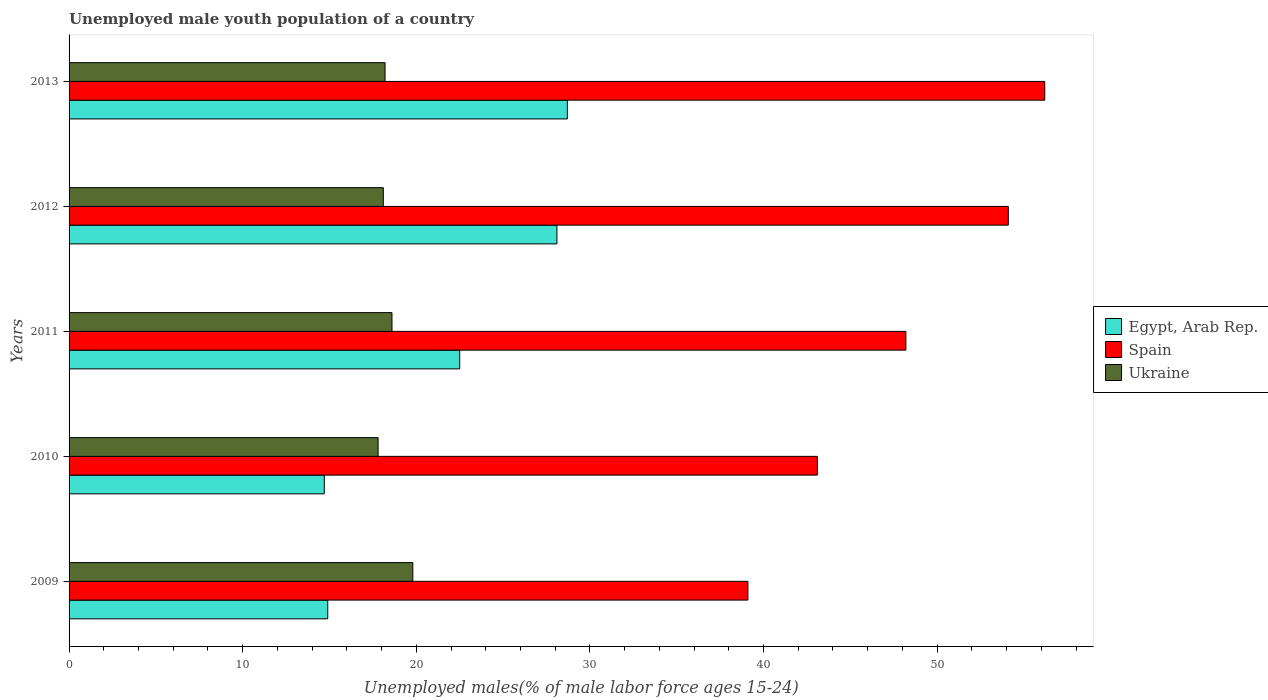How many different coloured bars are there?
Provide a short and direct response. 3. Are the number of bars on each tick of the Y-axis equal?
Your answer should be very brief. Yes. How many bars are there on the 1st tick from the bottom?
Give a very brief answer. 3. What is the label of the 1st group of bars from the top?
Provide a short and direct response. 2013. In how many cases, is the number of bars for a given year not equal to the number of legend labels?
Make the answer very short. 0. What is the percentage of unemployed male youth population in Ukraine in 2011?
Provide a short and direct response. 18.6. Across all years, what is the maximum percentage of unemployed male youth population in Spain?
Keep it short and to the point. 56.2. Across all years, what is the minimum percentage of unemployed male youth population in Spain?
Offer a very short reply. 39.1. What is the total percentage of unemployed male youth population in Ukraine in the graph?
Give a very brief answer. 92.5. What is the difference between the percentage of unemployed male youth population in Egypt, Arab Rep. in 2009 and that in 2010?
Your answer should be compact. 0.2. What is the difference between the percentage of unemployed male youth population in Egypt, Arab Rep. in 2009 and the percentage of unemployed male youth population in Spain in 2013?
Your answer should be compact. -41.3. What is the average percentage of unemployed male youth population in Ukraine per year?
Offer a terse response. 18.5. In the year 2009, what is the difference between the percentage of unemployed male youth population in Egypt, Arab Rep. and percentage of unemployed male youth population in Ukraine?
Offer a terse response. -4.9. In how many years, is the percentage of unemployed male youth population in Ukraine greater than 18 %?
Make the answer very short. 4. What is the ratio of the percentage of unemployed male youth population in Egypt, Arab Rep. in 2011 to that in 2012?
Your answer should be very brief. 0.8. Is the difference between the percentage of unemployed male youth population in Egypt, Arab Rep. in 2011 and 2013 greater than the difference between the percentage of unemployed male youth population in Ukraine in 2011 and 2013?
Provide a short and direct response. No. What is the difference between the highest and the second highest percentage of unemployed male youth population in Spain?
Provide a succinct answer. 2.1. What is the difference between the highest and the lowest percentage of unemployed male youth population in Spain?
Give a very brief answer. 17.1. What does the 3rd bar from the top in 2013 represents?
Give a very brief answer. Egypt, Arab Rep. What does the 1st bar from the bottom in 2010 represents?
Your answer should be very brief. Egypt, Arab Rep. Is it the case that in every year, the sum of the percentage of unemployed male youth population in Ukraine and percentage of unemployed male youth population in Spain is greater than the percentage of unemployed male youth population in Egypt, Arab Rep.?
Offer a very short reply. Yes. Are all the bars in the graph horizontal?
Provide a short and direct response. Yes. What is the difference between two consecutive major ticks on the X-axis?
Provide a succinct answer. 10. Are the values on the major ticks of X-axis written in scientific E-notation?
Offer a very short reply. No. Does the graph contain grids?
Keep it short and to the point. No. Where does the legend appear in the graph?
Provide a short and direct response. Center right. How many legend labels are there?
Give a very brief answer. 3. How are the legend labels stacked?
Provide a short and direct response. Vertical. What is the title of the graph?
Keep it short and to the point. Unemployed male youth population of a country. What is the label or title of the X-axis?
Keep it short and to the point. Unemployed males(% of male labor force ages 15-24). What is the label or title of the Y-axis?
Make the answer very short. Years. What is the Unemployed males(% of male labor force ages 15-24) of Egypt, Arab Rep. in 2009?
Give a very brief answer. 14.9. What is the Unemployed males(% of male labor force ages 15-24) in Spain in 2009?
Your answer should be very brief. 39.1. What is the Unemployed males(% of male labor force ages 15-24) in Ukraine in 2009?
Ensure brevity in your answer.  19.8. What is the Unemployed males(% of male labor force ages 15-24) in Egypt, Arab Rep. in 2010?
Your answer should be compact. 14.7. What is the Unemployed males(% of male labor force ages 15-24) in Spain in 2010?
Provide a succinct answer. 43.1. What is the Unemployed males(% of male labor force ages 15-24) of Ukraine in 2010?
Give a very brief answer. 17.8. What is the Unemployed males(% of male labor force ages 15-24) in Spain in 2011?
Make the answer very short. 48.2. What is the Unemployed males(% of male labor force ages 15-24) in Ukraine in 2011?
Provide a short and direct response. 18.6. What is the Unemployed males(% of male labor force ages 15-24) of Egypt, Arab Rep. in 2012?
Keep it short and to the point. 28.1. What is the Unemployed males(% of male labor force ages 15-24) of Spain in 2012?
Ensure brevity in your answer.  54.1. What is the Unemployed males(% of male labor force ages 15-24) of Ukraine in 2012?
Give a very brief answer. 18.1. What is the Unemployed males(% of male labor force ages 15-24) in Egypt, Arab Rep. in 2013?
Make the answer very short. 28.7. What is the Unemployed males(% of male labor force ages 15-24) of Spain in 2013?
Keep it short and to the point. 56.2. What is the Unemployed males(% of male labor force ages 15-24) of Ukraine in 2013?
Your answer should be very brief. 18.2. Across all years, what is the maximum Unemployed males(% of male labor force ages 15-24) in Egypt, Arab Rep.?
Your answer should be compact. 28.7. Across all years, what is the maximum Unemployed males(% of male labor force ages 15-24) in Spain?
Make the answer very short. 56.2. Across all years, what is the maximum Unemployed males(% of male labor force ages 15-24) in Ukraine?
Provide a short and direct response. 19.8. Across all years, what is the minimum Unemployed males(% of male labor force ages 15-24) of Egypt, Arab Rep.?
Provide a short and direct response. 14.7. Across all years, what is the minimum Unemployed males(% of male labor force ages 15-24) in Spain?
Provide a short and direct response. 39.1. Across all years, what is the minimum Unemployed males(% of male labor force ages 15-24) in Ukraine?
Give a very brief answer. 17.8. What is the total Unemployed males(% of male labor force ages 15-24) in Egypt, Arab Rep. in the graph?
Make the answer very short. 108.9. What is the total Unemployed males(% of male labor force ages 15-24) in Spain in the graph?
Your answer should be compact. 240.7. What is the total Unemployed males(% of male labor force ages 15-24) of Ukraine in the graph?
Your answer should be compact. 92.5. What is the difference between the Unemployed males(% of male labor force ages 15-24) of Spain in 2009 and that in 2010?
Your response must be concise. -4. What is the difference between the Unemployed males(% of male labor force ages 15-24) in Ukraine in 2009 and that in 2010?
Make the answer very short. 2. What is the difference between the Unemployed males(% of male labor force ages 15-24) in Egypt, Arab Rep. in 2009 and that in 2011?
Offer a very short reply. -7.6. What is the difference between the Unemployed males(% of male labor force ages 15-24) of Spain in 2009 and that in 2011?
Your answer should be very brief. -9.1. What is the difference between the Unemployed males(% of male labor force ages 15-24) of Ukraine in 2009 and that in 2011?
Give a very brief answer. 1.2. What is the difference between the Unemployed males(% of male labor force ages 15-24) of Egypt, Arab Rep. in 2009 and that in 2013?
Ensure brevity in your answer.  -13.8. What is the difference between the Unemployed males(% of male labor force ages 15-24) of Spain in 2009 and that in 2013?
Keep it short and to the point. -17.1. What is the difference between the Unemployed males(% of male labor force ages 15-24) in Ukraine in 2009 and that in 2013?
Offer a terse response. 1.6. What is the difference between the Unemployed males(% of male labor force ages 15-24) in Ukraine in 2010 and that in 2011?
Offer a terse response. -0.8. What is the difference between the Unemployed males(% of male labor force ages 15-24) in Egypt, Arab Rep. in 2010 and that in 2012?
Offer a very short reply. -13.4. What is the difference between the Unemployed males(% of male labor force ages 15-24) in Spain in 2010 and that in 2013?
Ensure brevity in your answer.  -13.1. What is the difference between the Unemployed males(% of male labor force ages 15-24) of Egypt, Arab Rep. in 2011 and that in 2012?
Give a very brief answer. -5.6. What is the difference between the Unemployed males(% of male labor force ages 15-24) of Spain in 2011 and that in 2012?
Offer a terse response. -5.9. What is the difference between the Unemployed males(% of male labor force ages 15-24) in Ukraine in 2011 and that in 2012?
Your answer should be compact. 0.5. What is the difference between the Unemployed males(% of male labor force ages 15-24) in Egypt, Arab Rep. in 2011 and that in 2013?
Your response must be concise. -6.2. What is the difference between the Unemployed males(% of male labor force ages 15-24) in Ukraine in 2011 and that in 2013?
Provide a succinct answer. 0.4. What is the difference between the Unemployed males(% of male labor force ages 15-24) in Spain in 2012 and that in 2013?
Give a very brief answer. -2.1. What is the difference between the Unemployed males(% of male labor force ages 15-24) in Ukraine in 2012 and that in 2013?
Your answer should be compact. -0.1. What is the difference between the Unemployed males(% of male labor force ages 15-24) in Egypt, Arab Rep. in 2009 and the Unemployed males(% of male labor force ages 15-24) in Spain in 2010?
Your answer should be very brief. -28.2. What is the difference between the Unemployed males(% of male labor force ages 15-24) of Egypt, Arab Rep. in 2009 and the Unemployed males(% of male labor force ages 15-24) of Ukraine in 2010?
Your response must be concise. -2.9. What is the difference between the Unemployed males(% of male labor force ages 15-24) of Spain in 2009 and the Unemployed males(% of male labor force ages 15-24) of Ukraine in 2010?
Keep it short and to the point. 21.3. What is the difference between the Unemployed males(% of male labor force ages 15-24) of Egypt, Arab Rep. in 2009 and the Unemployed males(% of male labor force ages 15-24) of Spain in 2011?
Offer a terse response. -33.3. What is the difference between the Unemployed males(% of male labor force ages 15-24) in Spain in 2009 and the Unemployed males(% of male labor force ages 15-24) in Ukraine in 2011?
Provide a succinct answer. 20.5. What is the difference between the Unemployed males(% of male labor force ages 15-24) in Egypt, Arab Rep. in 2009 and the Unemployed males(% of male labor force ages 15-24) in Spain in 2012?
Your answer should be compact. -39.2. What is the difference between the Unemployed males(% of male labor force ages 15-24) in Egypt, Arab Rep. in 2009 and the Unemployed males(% of male labor force ages 15-24) in Spain in 2013?
Provide a succinct answer. -41.3. What is the difference between the Unemployed males(% of male labor force ages 15-24) in Spain in 2009 and the Unemployed males(% of male labor force ages 15-24) in Ukraine in 2013?
Keep it short and to the point. 20.9. What is the difference between the Unemployed males(% of male labor force ages 15-24) of Egypt, Arab Rep. in 2010 and the Unemployed males(% of male labor force ages 15-24) of Spain in 2011?
Ensure brevity in your answer.  -33.5. What is the difference between the Unemployed males(% of male labor force ages 15-24) in Egypt, Arab Rep. in 2010 and the Unemployed males(% of male labor force ages 15-24) in Spain in 2012?
Make the answer very short. -39.4. What is the difference between the Unemployed males(% of male labor force ages 15-24) of Egypt, Arab Rep. in 2010 and the Unemployed males(% of male labor force ages 15-24) of Ukraine in 2012?
Give a very brief answer. -3.4. What is the difference between the Unemployed males(% of male labor force ages 15-24) of Egypt, Arab Rep. in 2010 and the Unemployed males(% of male labor force ages 15-24) of Spain in 2013?
Keep it short and to the point. -41.5. What is the difference between the Unemployed males(% of male labor force ages 15-24) of Egypt, Arab Rep. in 2010 and the Unemployed males(% of male labor force ages 15-24) of Ukraine in 2013?
Your answer should be compact. -3.5. What is the difference between the Unemployed males(% of male labor force ages 15-24) in Spain in 2010 and the Unemployed males(% of male labor force ages 15-24) in Ukraine in 2013?
Your answer should be very brief. 24.9. What is the difference between the Unemployed males(% of male labor force ages 15-24) in Egypt, Arab Rep. in 2011 and the Unemployed males(% of male labor force ages 15-24) in Spain in 2012?
Provide a short and direct response. -31.6. What is the difference between the Unemployed males(% of male labor force ages 15-24) in Spain in 2011 and the Unemployed males(% of male labor force ages 15-24) in Ukraine in 2012?
Give a very brief answer. 30.1. What is the difference between the Unemployed males(% of male labor force ages 15-24) in Egypt, Arab Rep. in 2011 and the Unemployed males(% of male labor force ages 15-24) in Spain in 2013?
Keep it short and to the point. -33.7. What is the difference between the Unemployed males(% of male labor force ages 15-24) in Egypt, Arab Rep. in 2011 and the Unemployed males(% of male labor force ages 15-24) in Ukraine in 2013?
Provide a short and direct response. 4.3. What is the difference between the Unemployed males(% of male labor force ages 15-24) in Spain in 2011 and the Unemployed males(% of male labor force ages 15-24) in Ukraine in 2013?
Offer a very short reply. 30. What is the difference between the Unemployed males(% of male labor force ages 15-24) in Egypt, Arab Rep. in 2012 and the Unemployed males(% of male labor force ages 15-24) in Spain in 2013?
Give a very brief answer. -28.1. What is the difference between the Unemployed males(% of male labor force ages 15-24) in Spain in 2012 and the Unemployed males(% of male labor force ages 15-24) in Ukraine in 2013?
Your answer should be very brief. 35.9. What is the average Unemployed males(% of male labor force ages 15-24) of Egypt, Arab Rep. per year?
Your response must be concise. 21.78. What is the average Unemployed males(% of male labor force ages 15-24) of Spain per year?
Give a very brief answer. 48.14. In the year 2009, what is the difference between the Unemployed males(% of male labor force ages 15-24) in Egypt, Arab Rep. and Unemployed males(% of male labor force ages 15-24) in Spain?
Offer a very short reply. -24.2. In the year 2009, what is the difference between the Unemployed males(% of male labor force ages 15-24) of Spain and Unemployed males(% of male labor force ages 15-24) of Ukraine?
Your answer should be compact. 19.3. In the year 2010, what is the difference between the Unemployed males(% of male labor force ages 15-24) in Egypt, Arab Rep. and Unemployed males(% of male labor force ages 15-24) in Spain?
Your answer should be very brief. -28.4. In the year 2010, what is the difference between the Unemployed males(% of male labor force ages 15-24) of Spain and Unemployed males(% of male labor force ages 15-24) of Ukraine?
Provide a succinct answer. 25.3. In the year 2011, what is the difference between the Unemployed males(% of male labor force ages 15-24) in Egypt, Arab Rep. and Unemployed males(% of male labor force ages 15-24) in Spain?
Your response must be concise. -25.7. In the year 2011, what is the difference between the Unemployed males(% of male labor force ages 15-24) of Spain and Unemployed males(% of male labor force ages 15-24) of Ukraine?
Provide a succinct answer. 29.6. In the year 2013, what is the difference between the Unemployed males(% of male labor force ages 15-24) of Egypt, Arab Rep. and Unemployed males(% of male labor force ages 15-24) of Spain?
Make the answer very short. -27.5. What is the ratio of the Unemployed males(% of male labor force ages 15-24) in Egypt, Arab Rep. in 2009 to that in 2010?
Provide a short and direct response. 1.01. What is the ratio of the Unemployed males(% of male labor force ages 15-24) in Spain in 2009 to that in 2010?
Keep it short and to the point. 0.91. What is the ratio of the Unemployed males(% of male labor force ages 15-24) in Ukraine in 2009 to that in 2010?
Your answer should be very brief. 1.11. What is the ratio of the Unemployed males(% of male labor force ages 15-24) in Egypt, Arab Rep. in 2009 to that in 2011?
Offer a very short reply. 0.66. What is the ratio of the Unemployed males(% of male labor force ages 15-24) of Spain in 2009 to that in 2011?
Make the answer very short. 0.81. What is the ratio of the Unemployed males(% of male labor force ages 15-24) in Ukraine in 2009 to that in 2011?
Offer a terse response. 1.06. What is the ratio of the Unemployed males(% of male labor force ages 15-24) in Egypt, Arab Rep. in 2009 to that in 2012?
Give a very brief answer. 0.53. What is the ratio of the Unemployed males(% of male labor force ages 15-24) in Spain in 2009 to that in 2012?
Give a very brief answer. 0.72. What is the ratio of the Unemployed males(% of male labor force ages 15-24) of Ukraine in 2009 to that in 2012?
Make the answer very short. 1.09. What is the ratio of the Unemployed males(% of male labor force ages 15-24) of Egypt, Arab Rep. in 2009 to that in 2013?
Provide a short and direct response. 0.52. What is the ratio of the Unemployed males(% of male labor force ages 15-24) of Spain in 2009 to that in 2013?
Your response must be concise. 0.7. What is the ratio of the Unemployed males(% of male labor force ages 15-24) in Ukraine in 2009 to that in 2013?
Provide a succinct answer. 1.09. What is the ratio of the Unemployed males(% of male labor force ages 15-24) in Egypt, Arab Rep. in 2010 to that in 2011?
Your response must be concise. 0.65. What is the ratio of the Unemployed males(% of male labor force ages 15-24) in Spain in 2010 to that in 2011?
Make the answer very short. 0.89. What is the ratio of the Unemployed males(% of male labor force ages 15-24) in Ukraine in 2010 to that in 2011?
Your answer should be compact. 0.96. What is the ratio of the Unemployed males(% of male labor force ages 15-24) in Egypt, Arab Rep. in 2010 to that in 2012?
Ensure brevity in your answer.  0.52. What is the ratio of the Unemployed males(% of male labor force ages 15-24) of Spain in 2010 to that in 2012?
Your answer should be very brief. 0.8. What is the ratio of the Unemployed males(% of male labor force ages 15-24) in Ukraine in 2010 to that in 2012?
Keep it short and to the point. 0.98. What is the ratio of the Unemployed males(% of male labor force ages 15-24) in Egypt, Arab Rep. in 2010 to that in 2013?
Your answer should be compact. 0.51. What is the ratio of the Unemployed males(% of male labor force ages 15-24) of Spain in 2010 to that in 2013?
Ensure brevity in your answer.  0.77. What is the ratio of the Unemployed males(% of male labor force ages 15-24) of Egypt, Arab Rep. in 2011 to that in 2012?
Provide a succinct answer. 0.8. What is the ratio of the Unemployed males(% of male labor force ages 15-24) in Spain in 2011 to that in 2012?
Ensure brevity in your answer.  0.89. What is the ratio of the Unemployed males(% of male labor force ages 15-24) of Ukraine in 2011 to that in 2012?
Provide a succinct answer. 1.03. What is the ratio of the Unemployed males(% of male labor force ages 15-24) in Egypt, Arab Rep. in 2011 to that in 2013?
Your response must be concise. 0.78. What is the ratio of the Unemployed males(% of male labor force ages 15-24) of Spain in 2011 to that in 2013?
Provide a succinct answer. 0.86. What is the ratio of the Unemployed males(% of male labor force ages 15-24) of Egypt, Arab Rep. in 2012 to that in 2013?
Offer a very short reply. 0.98. What is the ratio of the Unemployed males(% of male labor force ages 15-24) in Spain in 2012 to that in 2013?
Your answer should be compact. 0.96. What is the difference between the highest and the second highest Unemployed males(% of male labor force ages 15-24) in Egypt, Arab Rep.?
Ensure brevity in your answer.  0.6. What is the difference between the highest and the second highest Unemployed males(% of male labor force ages 15-24) in Ukraine?
Keep it short and to the point. 1.2. What is the difference between the highest and the lowest Unemployed males(% of male labor force ages 15-24) in Egypt, Arab Rep.?
Offer a very short reply. 14. 